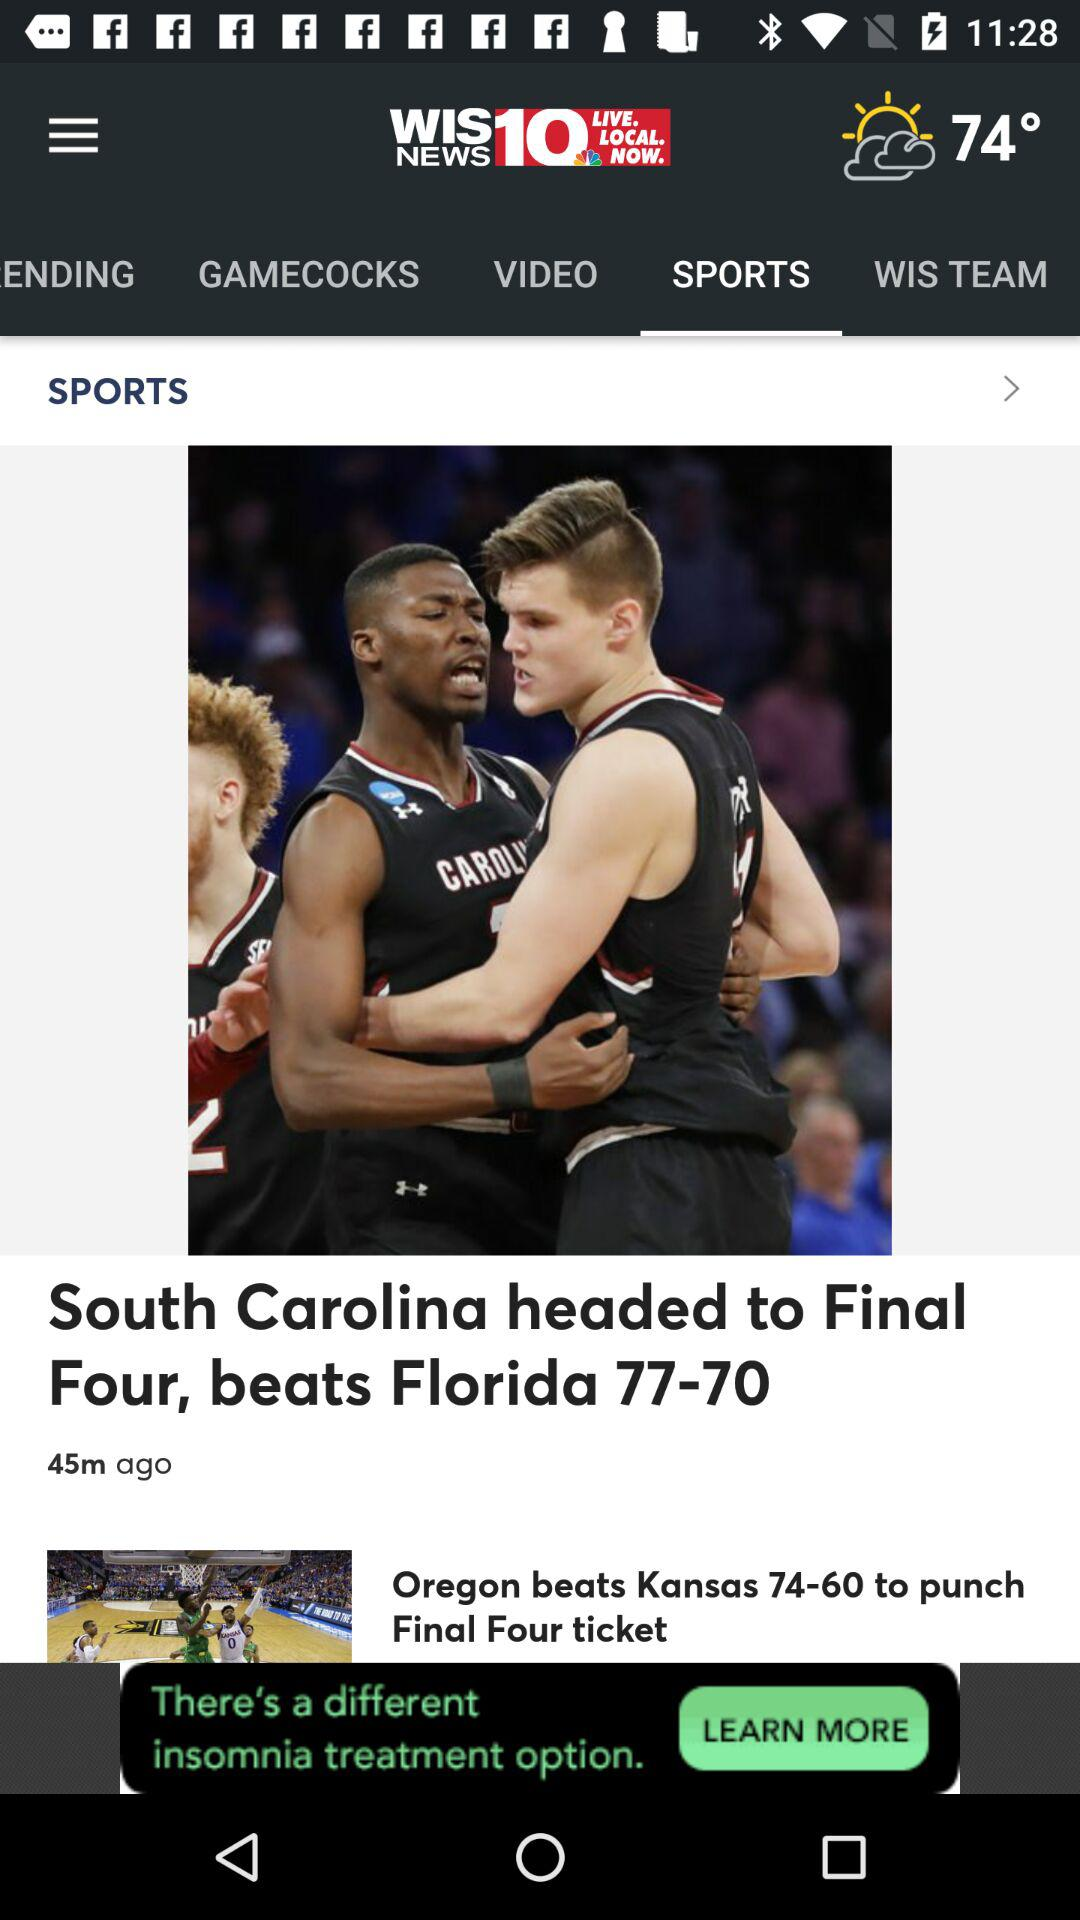What is the temperature? The temperature is 74°. 